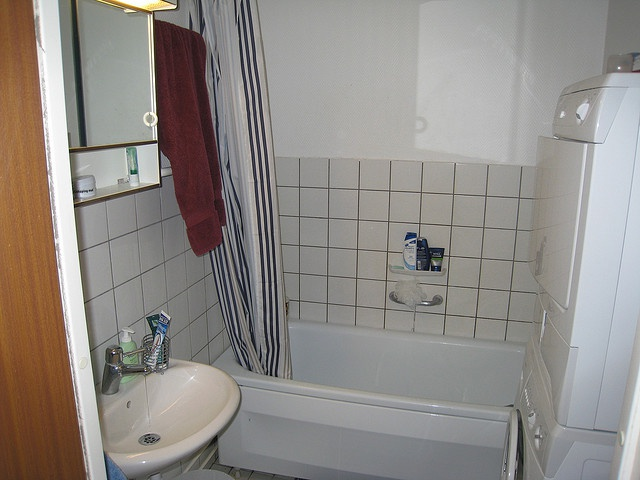Describe the objects in this image and their specific colors. I can see sink in maroon, darkgray, and gray tones, bottle in maroon, darkgray, and gray tones, bottle in maroon, darkgray, gray, and navy tones, and bottle in maroon, black, gray, and darkblue tones in this image. 